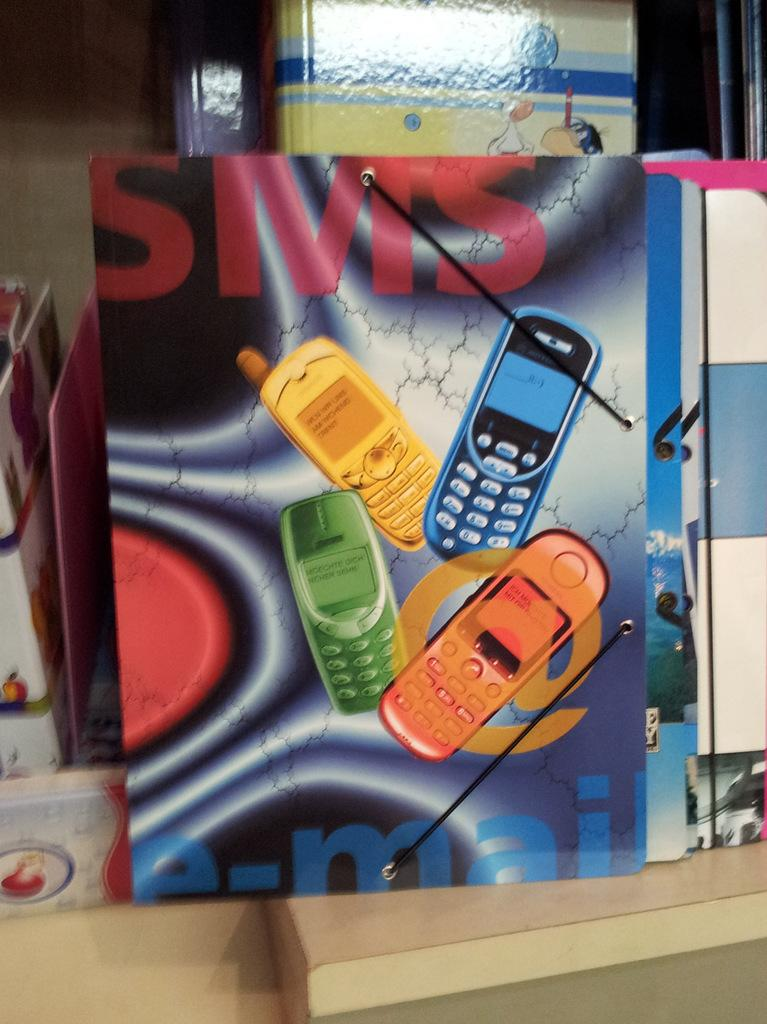<image>
Offer a succinct explanation of the picture presented. Four cellphones of different colors are shown under text that reads SMS. 